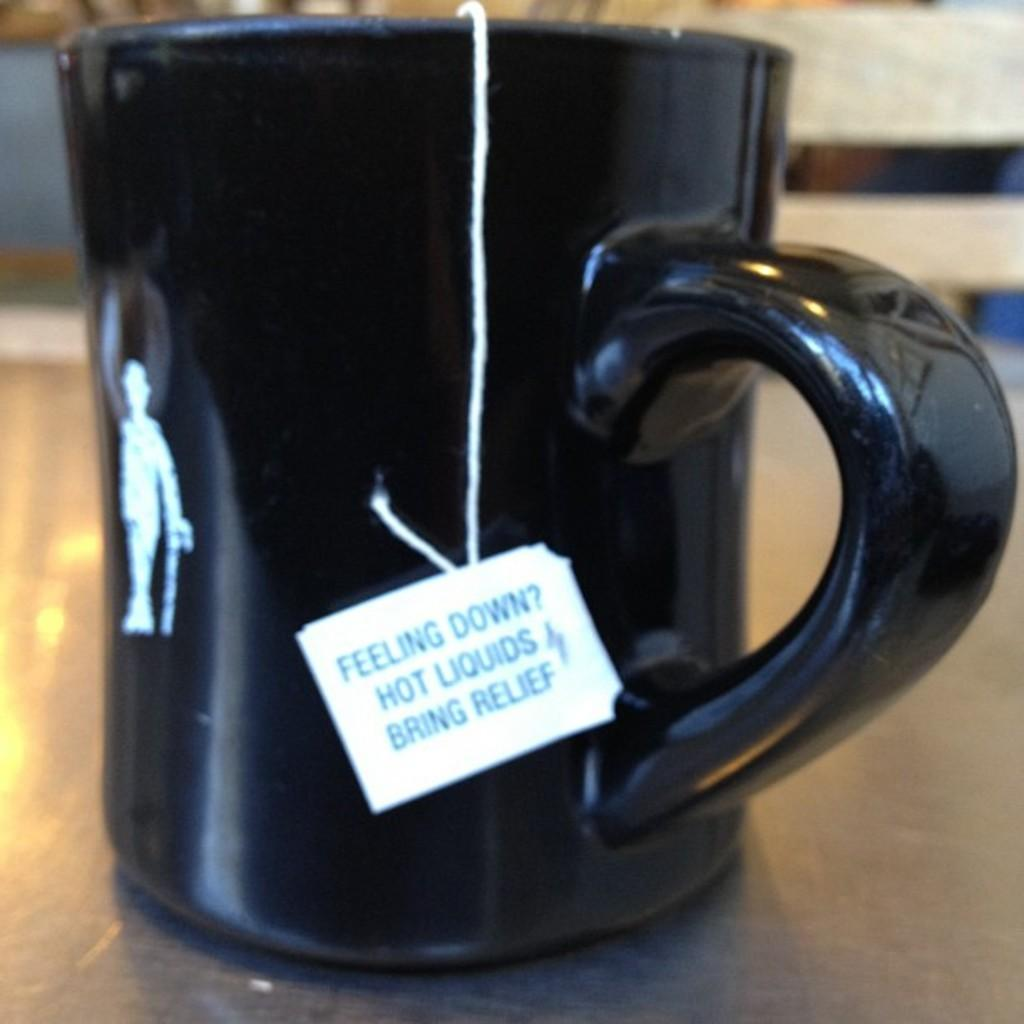What object can be seen in the image? There is a cup in the image. Is there any additional information about the cup? Yes, there is a tag attached to the cup. Where are the cup and tag located? Both the cup and tag are on a platform. Can you describe the background of the image? The background of the image is blurred. What type of soap is being used to clean the basket in the image? There is no basket or soap present in the image. 